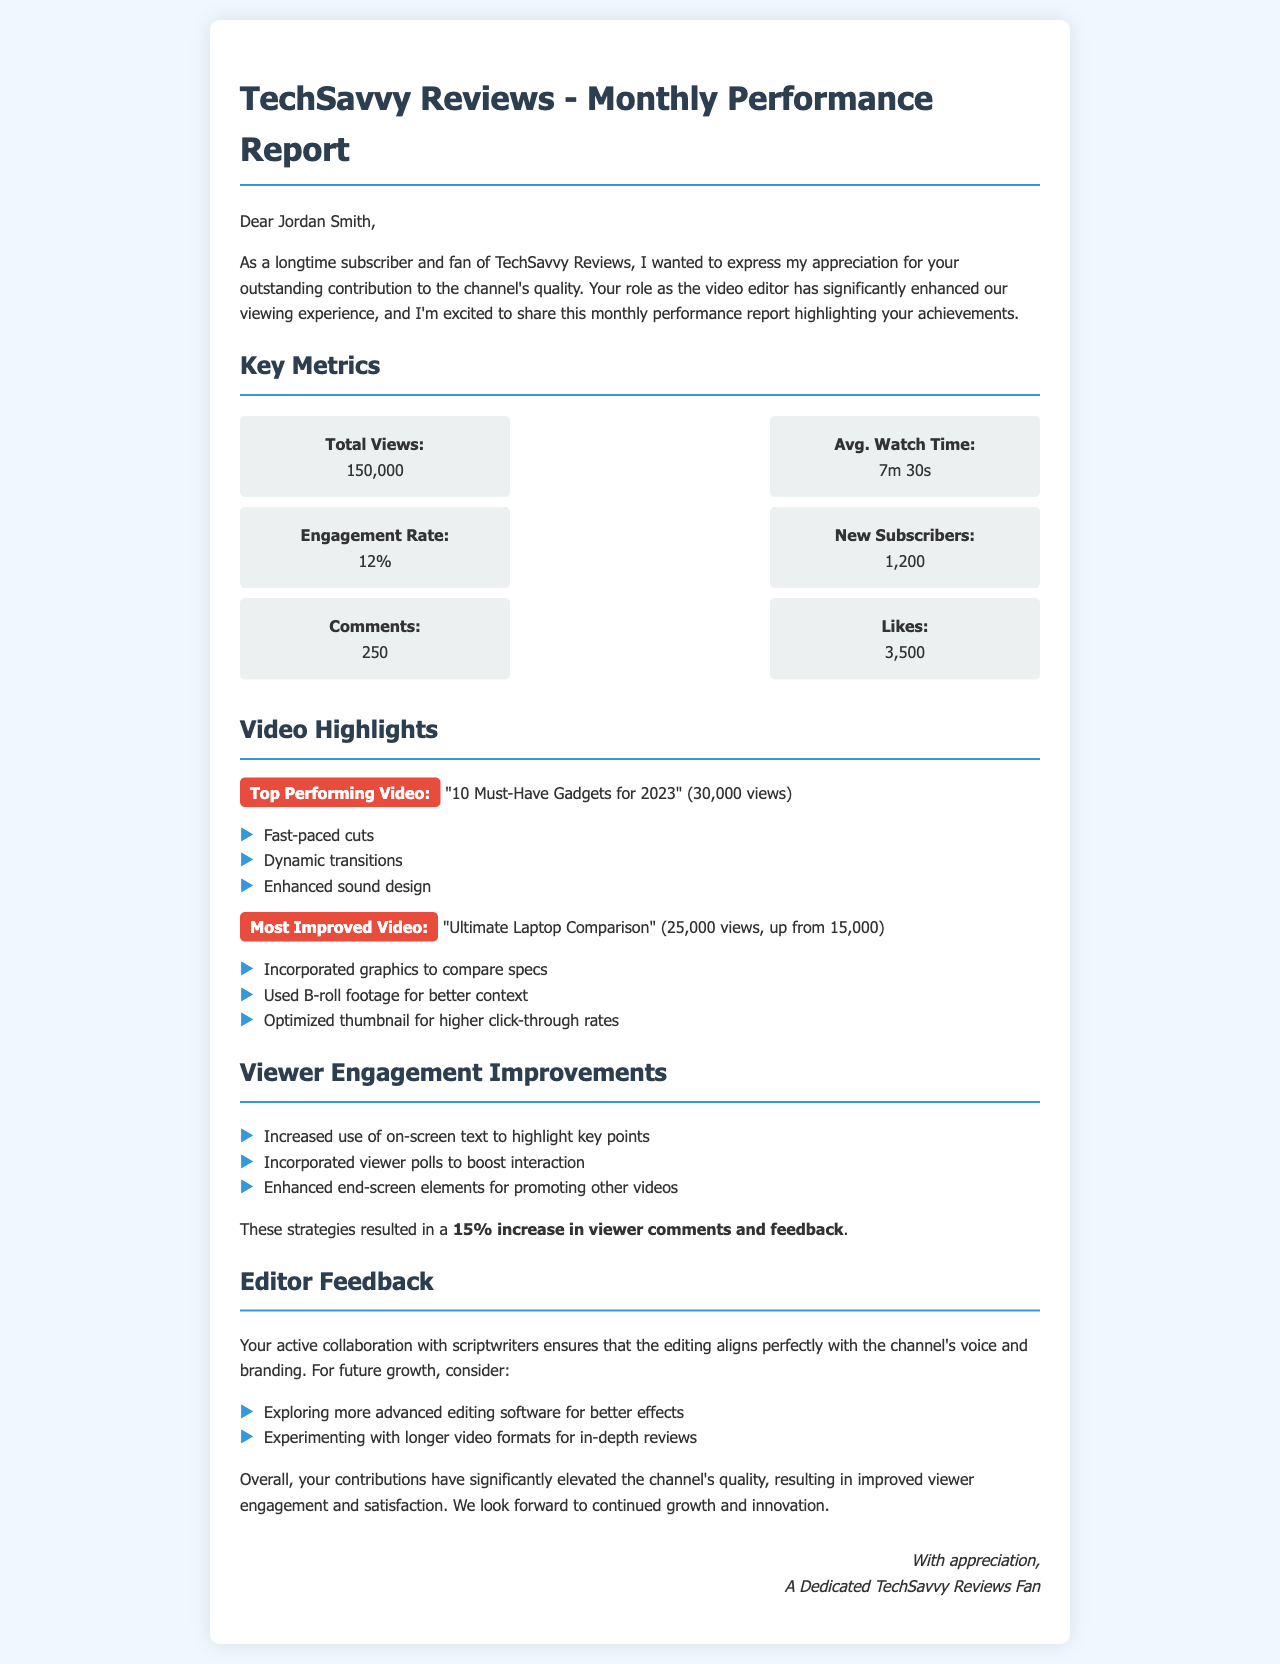What is the total number of views? The total number of views is explicitly stated in the metrics section of the report.
Answer: 150,000 What is the average watch time of the videos? The average watch time is provided in the metrics section of the report.
Answer: 7m 30s How many new subscribers were gained? The number of new subscribers is included in the key metrics.
Answer: 1,200 What is the engagement rate? The engagement rate is specifically mentioned in the metrics section of the document.
Answer: 12% Which video is the top performer? The top performing video is highlighted in the video highlights section.
Answer: "10 Must-Have Gadgets for 2023" What was the increase in views for the most improved video? The improvement in views for the most improved video is detailed in the video highlights section.
Answer: 10,000 What strategies led to a 15% increase in viewer comments? The strategies that resulted in the increase in comments are listed in the viewer engagement improvements.
Answer: Enhanced end-screen elements What does the editor collaborate with to ensure quality? The editor collaborates with scriptwriters for aligning the editing with the channel's voice.
Answer: Scriptwriters What is one suggestion for future growth mentioned in the report? Suggestions for future growth are provided in the editor feedback section of the report.
Answer: Exploring more advanced editing software 